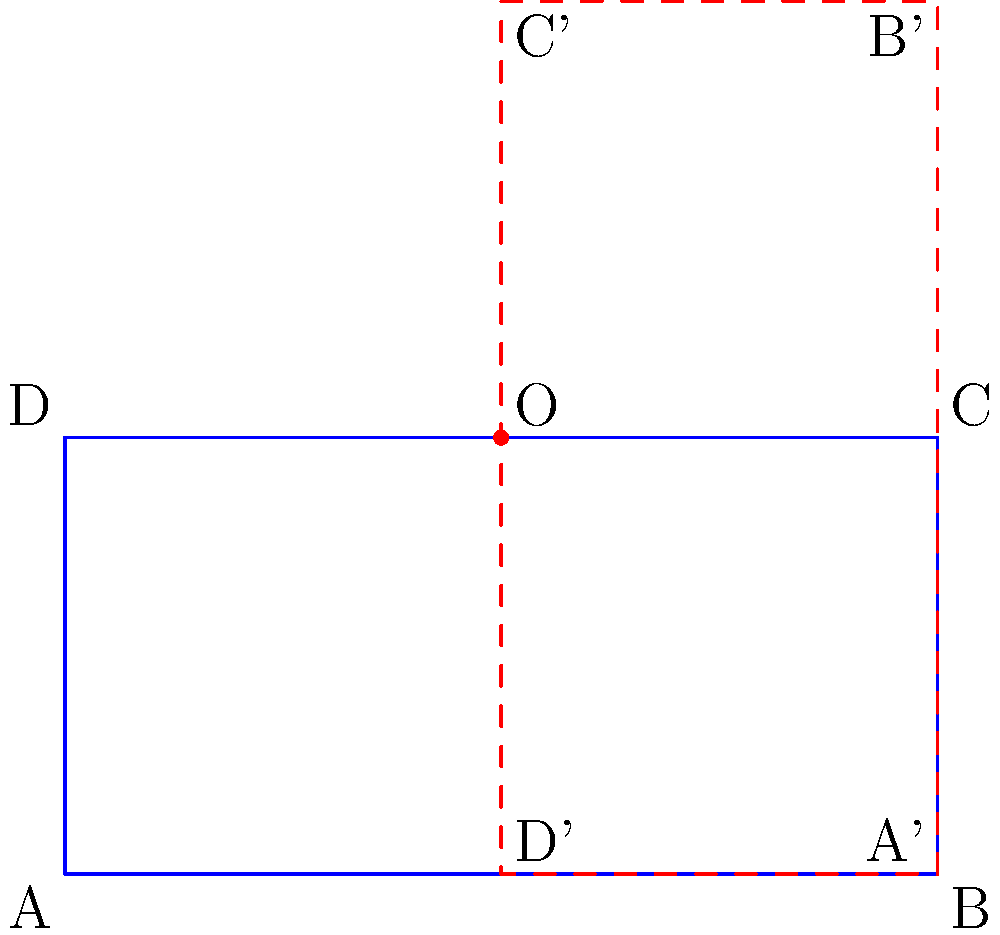Hey there! Remember that house-shaped figure we used to sketch during our chats? I've been thinking about it lately. If we rotate that house shape 90 degrees counterclockwise around point O, which is located at the top right corner of the original house, what would be the coordinates of point B after the rotation? Let's assume the original coordinates of B are (2,0). To find the coordinates of point B after rotation, we can follow these steps:

1) The rotation is 90 degrees counterclockwise around point O (1,1).

2) To rotate a point $(x,y)$ by 90 degrees counterclockwise around the origin, we use the formula: $(x,y) \rightarrow (-y,x)$

3) However, we're rotating around (1,1), not (0,0). So we need to:
   a) Translate the point so that O becomes the origin
   b) Rotate
   c) Translate back

4) Let's go through these steps:
   a) Translate B(2,0) by (-1,-1): $(2-1,0-1) = (1,-1)$
   b) Rotate (1,-1) by 90 degrees: $(-(-1),1) = (1,1)$
   c) Translate back by (1,1): $(1+1,1+1) = (2,2)$

5) Therefore, after rotation, point B will be at (2,2).
Answer: (2,2) 